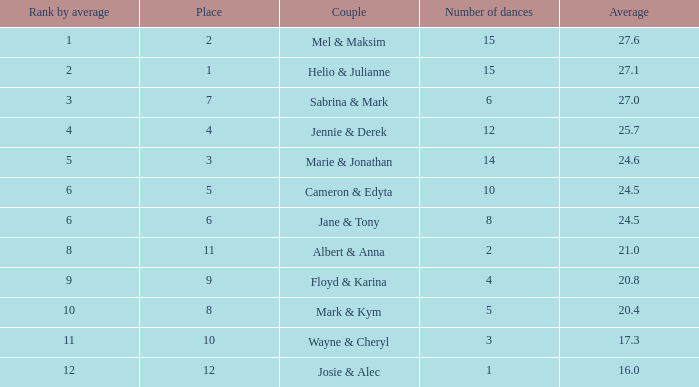What is the average place for a couple with the rank by average of 9 and total smaller than 83? None. 